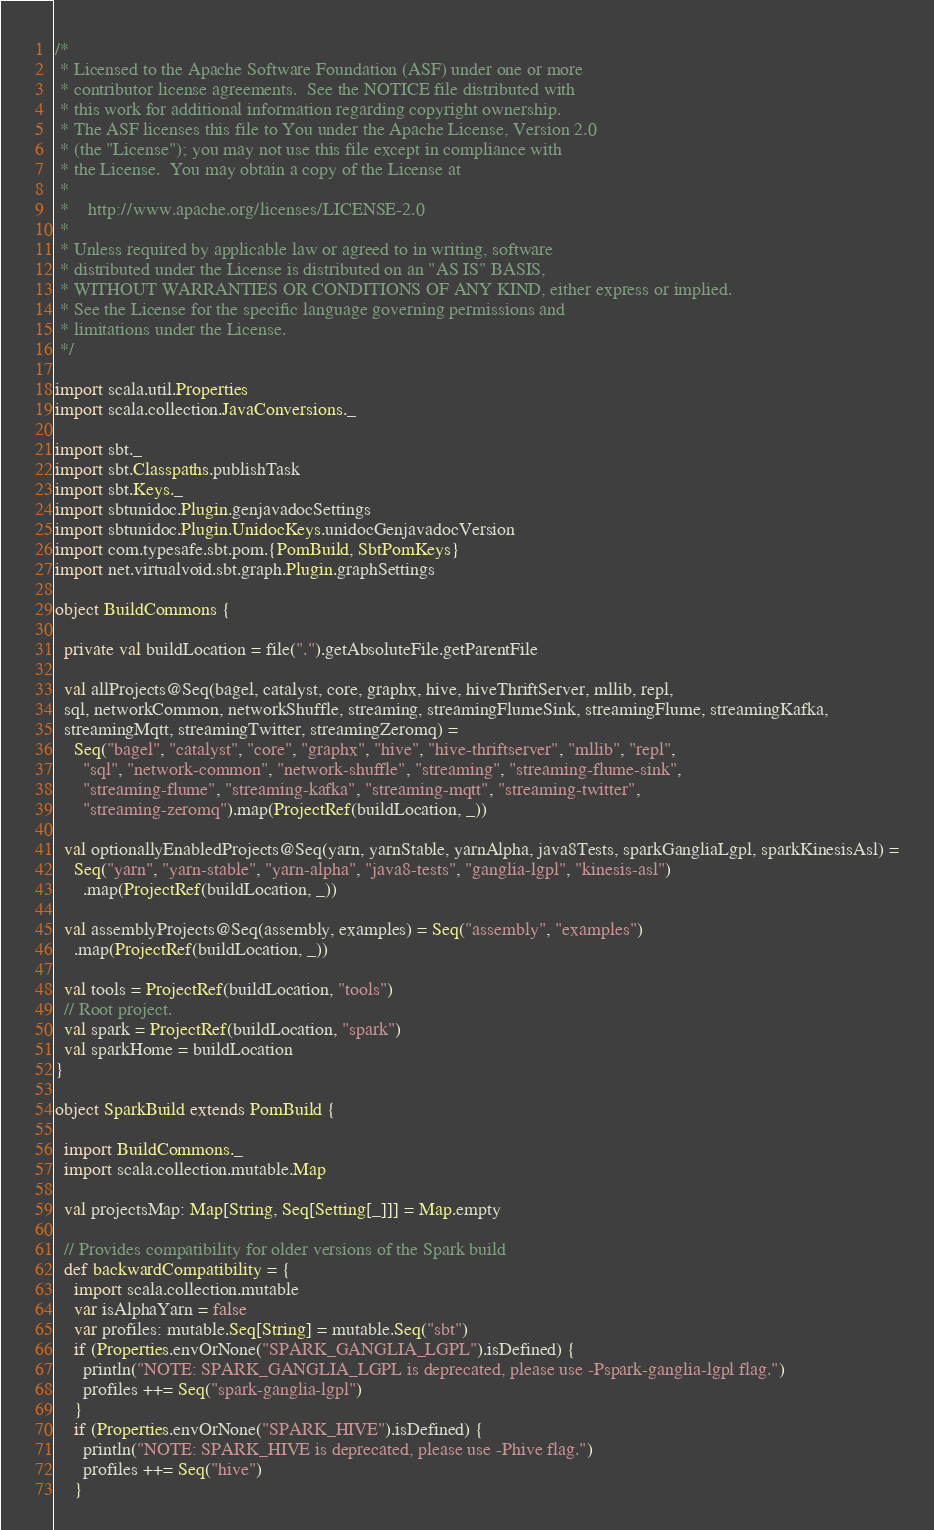<code> <loc_0><loc_0><loc_500><loc_500><_Scala_>/*
 * Licensed to the Apache Software Foundation (ASF) under one or more
 * contributor license agreements.  See the NOTICE file distributed with
 * this work for additional information regarding copyright ownership.
 * The ASF licenses this file to You under the Apache License, Version 2.0
 * (the "License"); you may not use this file except in compliance with
 * the License.  You may obtain a copy of the License at
 *
 *    http://www.apache.org/licenses/LICENSE-2.0
 *
 * Unless required by applicable law or agreed to in writing, software
 * distributed under the License is distributed on an "AS IS" BASIS,
 * WITHOUT WARRANTIES OR CONDITIONS OF ANY KIND, either express or implied.
 * See the License for the specific language governing permissions and
 * limitations under the License.
 */

import scala.util.Properties
import scala.collection.JavaConversions._

import sbt._
import sbt.Classpaths.publishTask
import sbt.Keys._
import sbtunidoc.Plugin.genjavadocSettings
import sbtunidoc.Plugin.UnidocKeys.unidocGenjavadocVersion
import com.typesafe.sbt.pom.{PomBuild, SbtPomKeys}
import net.virtualvoid.sbt.graph.Plugin.graphSettings

object BuildCommons {

  private val buildLocation = file(".").getAbsoluteFile.getParentFile

  val allProjects@Seq(bagel, catalyst, core, graphx, hive, hiveThriftServer, mllib, repl,
  sql, networkCommon, networkShuffle, streaming, streamingFlumeSink, streamingFlume, streamingKafka,
  streamingMqtt, streamingTwitter, streamingZeromq) =
    Seq("bagel", "catalyst", "core", "graphx", "hive", "hive-thriftserver", "mllib", "repl",
      "sql", "network-common", "network-shuffle", "streaming", "streaming-flume-sink",
      "streaming-flume", "streaming-kafka", "streaming-mqtt", "streaming-twitter",
      "streaming-zeromq").map(ProjectRef(buildLocation, _))

  val optionallyEnabledProjects@Seq(yarn, yarnStable, yarnAlpha, java8Tests, sparkGangliaLgpl, sparkKinesisAsl) =
    Seq("yarn", "yarn-stable", "yarn-alpha", "java8-tests", "ganglia-lgpl", "kinesis-asl")
      .map(ProjectRef(buildLocation, _))

  val assemblyProjects@Seq(assembly, examples) = Seq("assembly", "examples")
    .map(ProjectRef(buildLocation, _))

  val tools = ProjectRef(buildLocation, "tools")
  // Root project.
  val spark = ProjectRef(buildLocation, "spark")
  val sparkHome = buildLocation
}

object SparkBuild extends PomBuild {

  import BuildCommons._
  import scala.collection.mutable.Map

  val projectsMap: Map[String, Seq[Setting[_]]] = Map.empty

  // Provides compatibility for older versions of the Spark build
  def backwardCompatibility = {
    import scala.collection.mutable
    var isAlphaYarn = false
    var profiles: mutable.Seq[String] = mutable.Seq("sbt")
    if (Properties.envOrNone("SPARK_GANGLIA_LGPL").isDefined) {
      println("NOTE: SPARK_GANGLIA_LGPL is deprecated, please use -Pspark-ganglia-lgpl flag.")
      profiles ++= Seq("spark-ganglia-lgpl")
    }
    if (Properties.envOrNone("SPARK_HIVE").isDefined) {
      println("NOTE: SPARK_HIVE is deprecated, please use -Phive flag.")
      profiles ++= Seq("hive")
    }</code> 